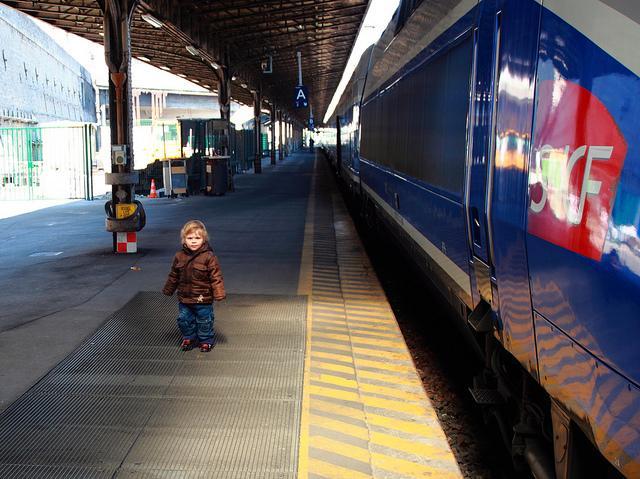What is this child's parent doing? Please explain your reasoning. taking photograph. The child is getting their picture taken. 